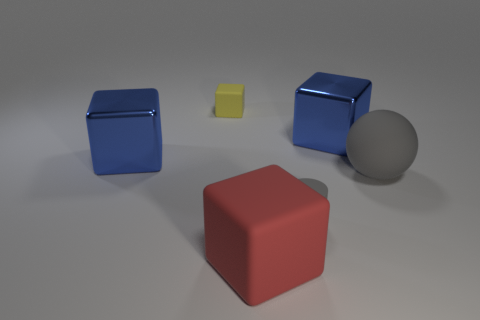There is a yellow thing that is the same size as the gray cylinder; what material is it?
Keep it short and to the point. Rubber. There is a gray rubber object that is on the right side of the gray matte cylinder; does it have the same size as the tiny yellow object?
Keep it short and to the point. No. What number of balls are either large gray matte objects or cyan metal things?
Ensure brevity in your answer.  1. There is a gray thing that is on the right side of the small gray thing; what is it made of?
Your response must be concise. Rubber. Are there fewer big metallic objects than small matte blocks?
Provide a short and direct response. No. What is the size of the rubber object that is behind the red matte thing and in front of the sphere?
Your answer should be very brief. Small. There is a rubber cube that is behind the small rubber thing in front of the big matte thing that is right of the matte cylinder; how big is it?
Make the answer very short. Small. What number of other things are the same color as the cylinder?
Provide a short and direct response. 1. Is the color of the cylinder that is on the left side of the large gray matte thing the same as the rubber sphere?
Offer a very short reply. Yes. What number of objects are either gray balls or tiny gray matte cylinders?
Give a very brief answer. 2. 